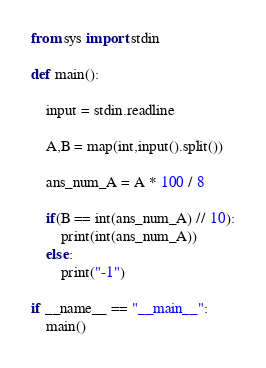<code> <loc_0><loc_0><loc_500><loc_500><_Python_>from sys import stdin

def main():

    input = stdin.readline

    A,B = map(int,input().split())

    ans_num_A = A * 100 / 8

    if(B == int(ans_num_A) // 10):
        print(int(ans_num_A))
    else:
        print("-1")

if __name__ == "__main__":
    main()</code> 